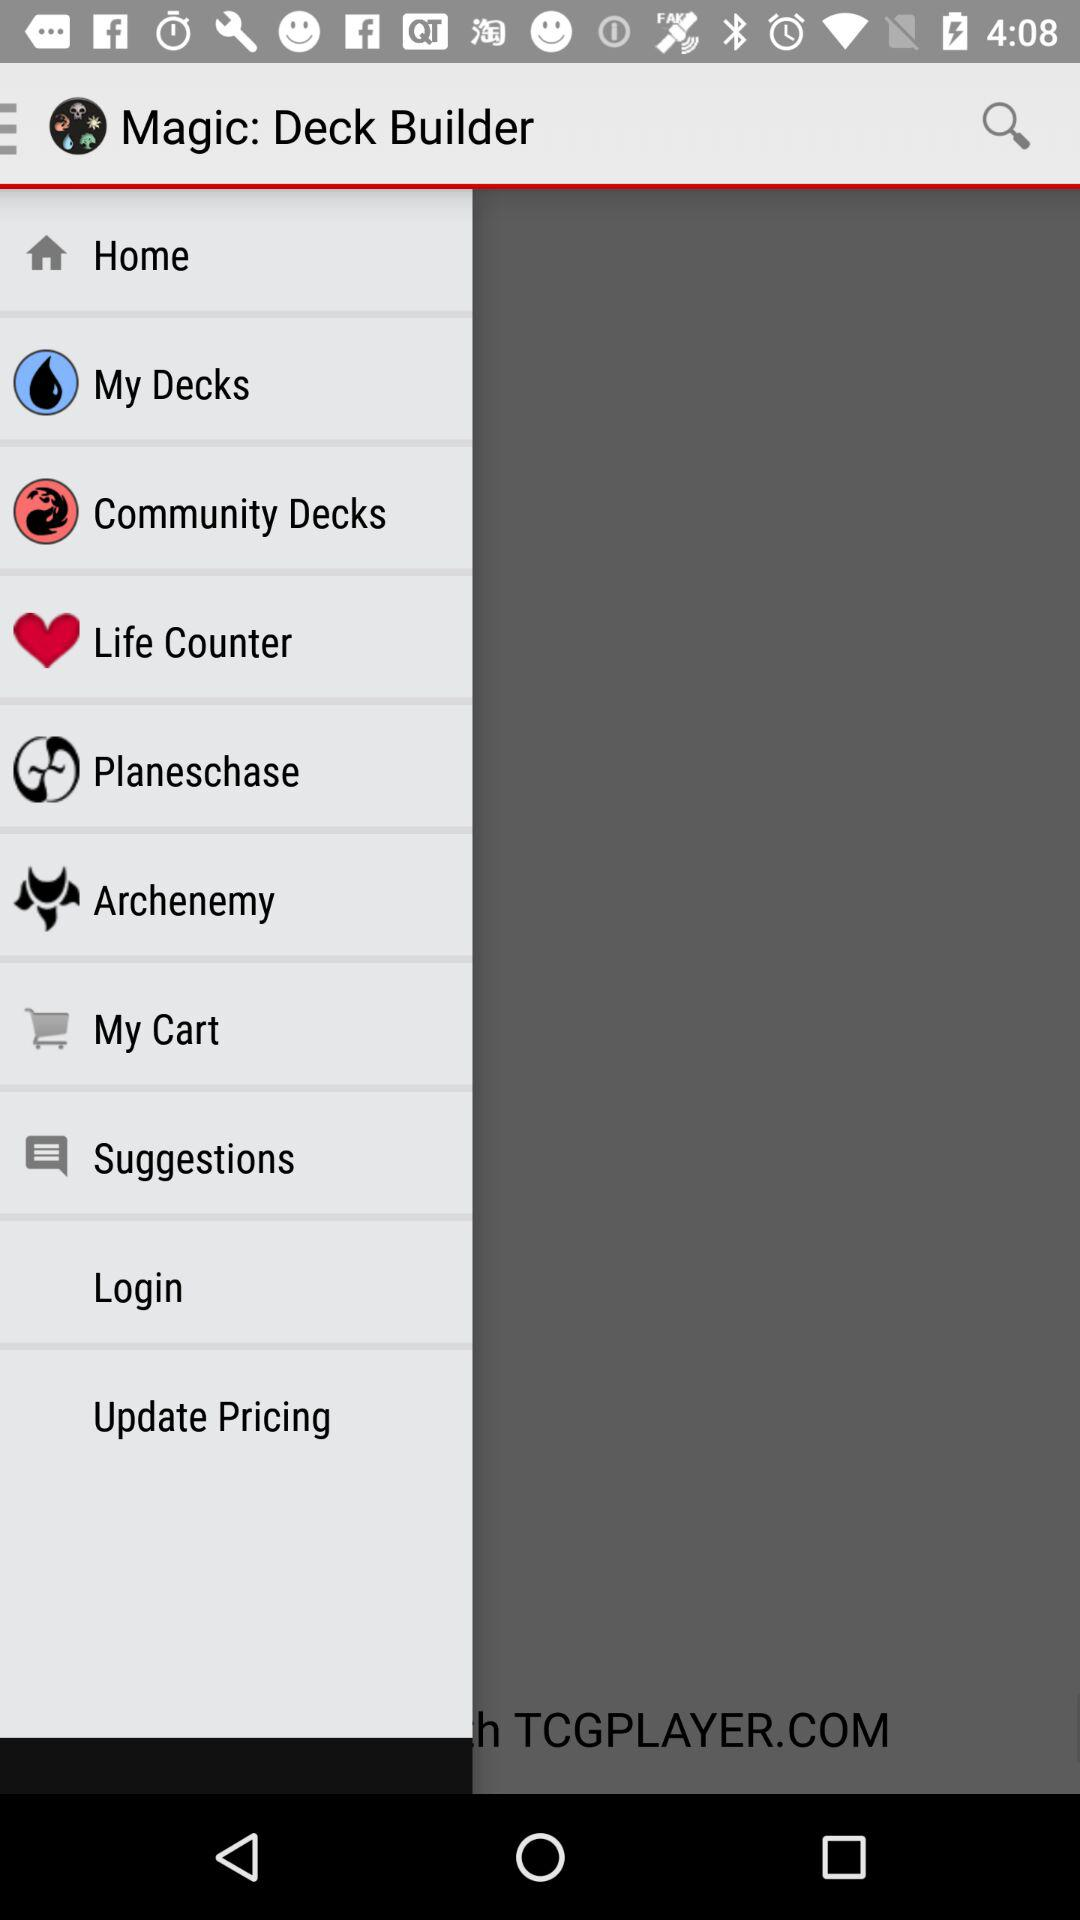What is the current page? The current page is 1. 